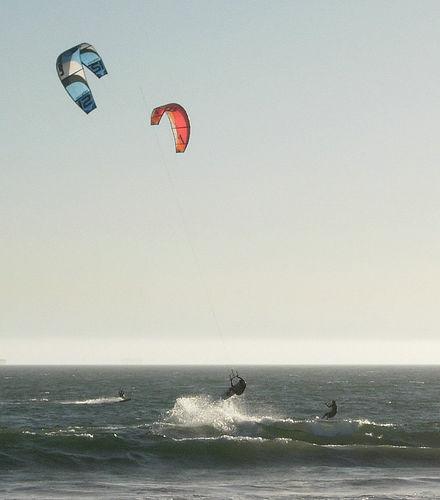What is this person doing?
Quick response, please. Windsurfing. Is there a pink and white kite under the blue sky?
Answer briefly. Yes. Is the wind making the kite fly?
Write a very short answer. Yes. Is it windy in the picture?
Keep it brief. Yes. When was this picture taken?
Write a very short answer. Daytime. Are those people staying safe?
Write a very short answer. Yes. 